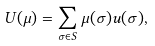Convert formula to latex. <formula><loc_0><loc_0><loc_500><loc_500>U ( \mu ) = \sum _ { \sigma \in S } \mu ( \sigma ) u ( \sigma ) ,</formula> 